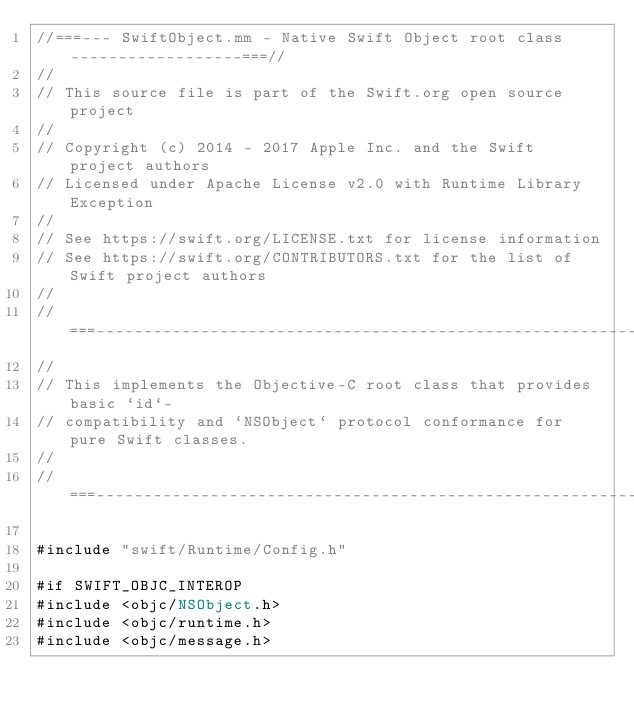Convert code to text. <code><loc_0><loc_0><loc_500><loc_500><_ObjectiveC_>//===--- SwiftObject.mm - Native Swift Object root class ------------------===//
//
// This source file is part of the Swift.org open source project
//
// Copyright (c) 2014 - 2017 Apple Inc. and the Swift project authors
// Licensed under Apache License v2.0 with Runtime Library Exception
//
// See https://swift.org/LICENSE.txt for license information
// See https://swift.org/CONTRIBUTORS.txt for the list of Swift project authors
//
//===----------------------------------------------------------------------===//
//
// This implements the Objective-C root class that provides basic `id`-
// compatibility and `NSObject` protocol conformance for pure Swift classes.
//
//===----------------------------------------------------------------------===//

#include "swift/Runtime/Config.h"

#if SWIFT_OBJC_INTEROP
#include <objc/NSObject.h>
#include <objc/runtime.h>
#include <objc/message.h></code> 